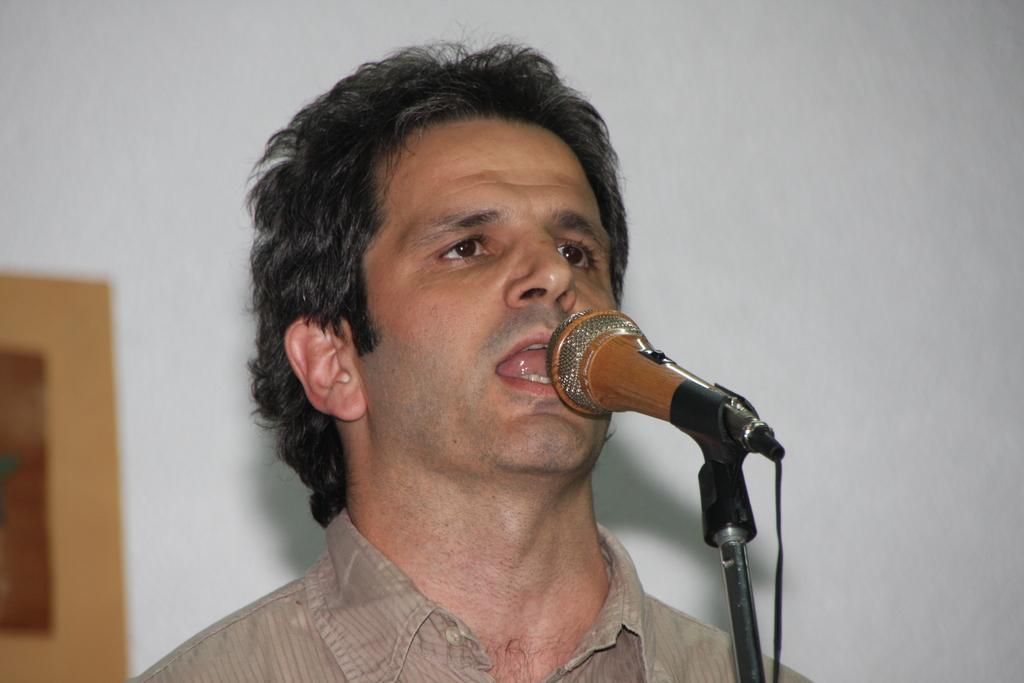How would you summarize this image in a sentence or two? This image is taken indoors. In the background there is a wall with a picture frame on it. In the middle of the image there is a man and he is singing on the mic. 